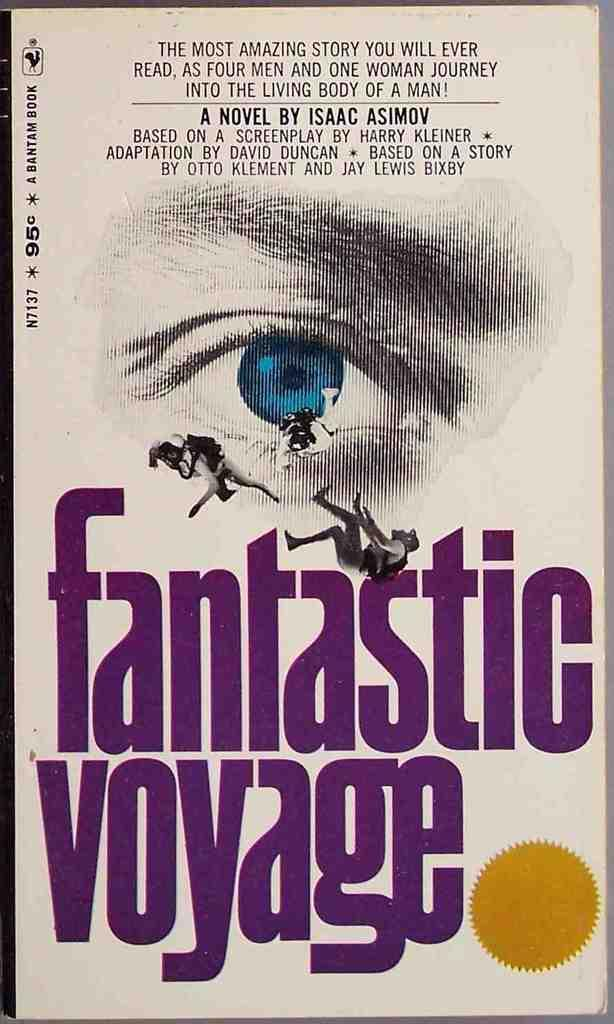<image>
Give a short and clear explanation of the subsequent image. The cover of the Fantastic Voyage includes a close-up of a blue eye. 